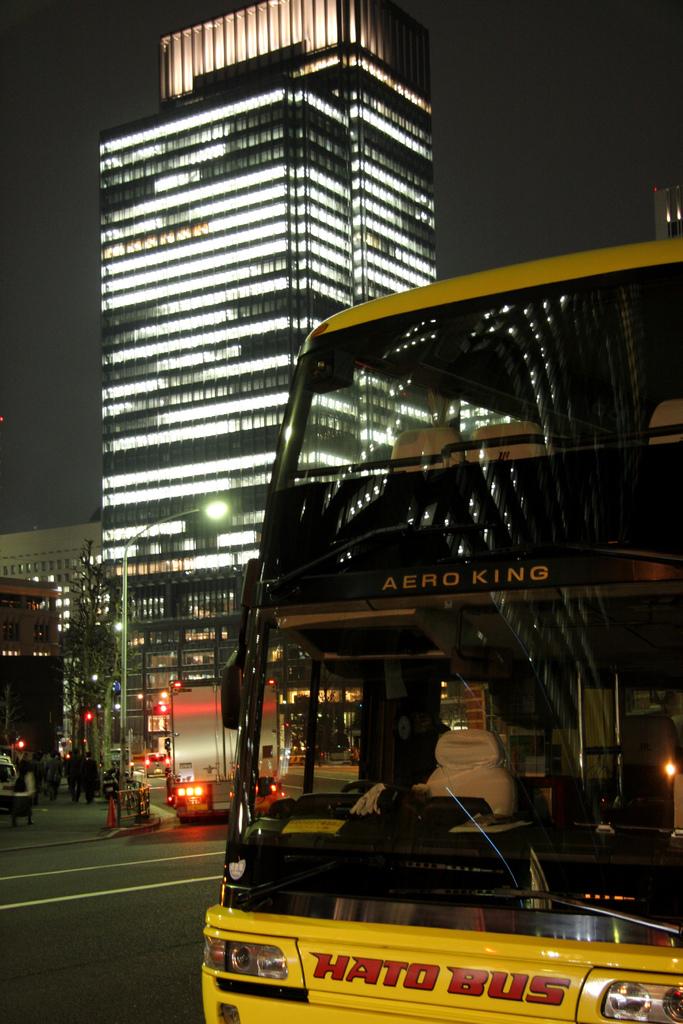What's the name of the king?
Keep it short and to the point. Aero. What is the name of this bus company?
Offer a terse response. Hato bus. 